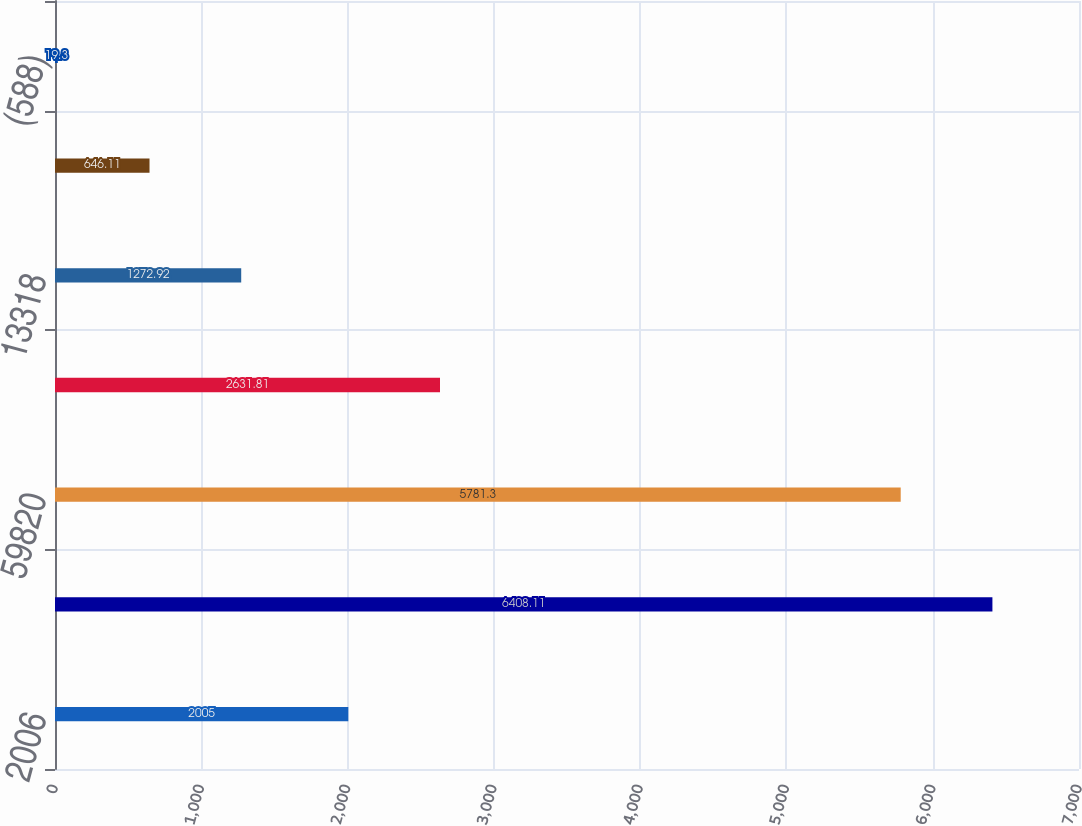Convert chart. <chart><loc_0><loc_0><loc_500><loc_500><bar_chart><fcel>2006<fcel>67409<fcel>59820<fcel>27187<fcel>13318<fcel>323<fcel>(588)<nl><fcel>2005<fcel>6408.11<fcel>5781.3<fcel>2631.81<fcel>1272.92<fcel>646.11<fcel>19.3<nl></chart> 